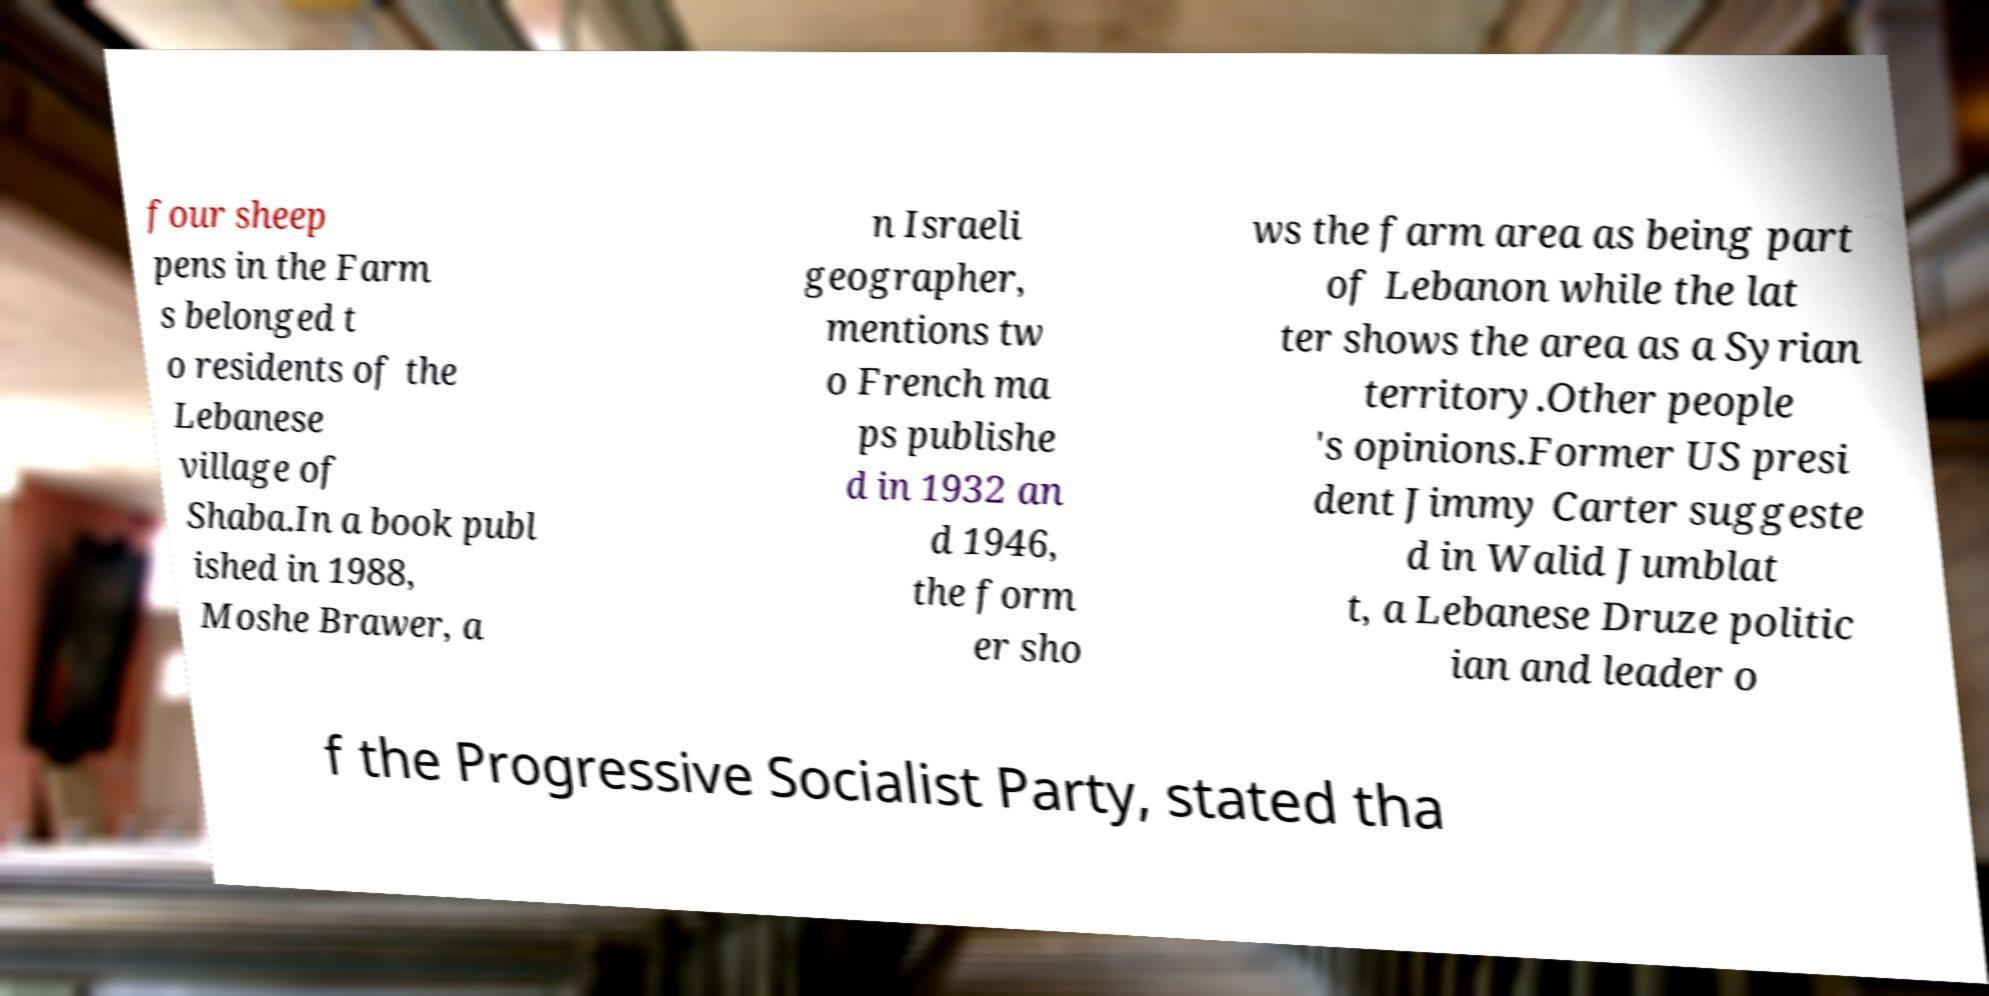What messages or text are displayed in this image? I need them in a readable, typed format. four sheep pens in the Farm s belonged t o residents of the Lebanese village of Shaba.In a book publ ished in 1988, Moshe Brawer, a n Israeli geographer, mentions tw o French ma ps publishe d in 1932 an d 1946, the form er sho ws the farm area as being part of Lebanon while the lat ter shows the area as a Syrian territory.Other people 's opinions.Former US presi dent Jimmy Carter suggeste d in Walid Jumblat t, a Lebanese Druze politic ian and leader o f the Progressive Socialist Party, stated tha 